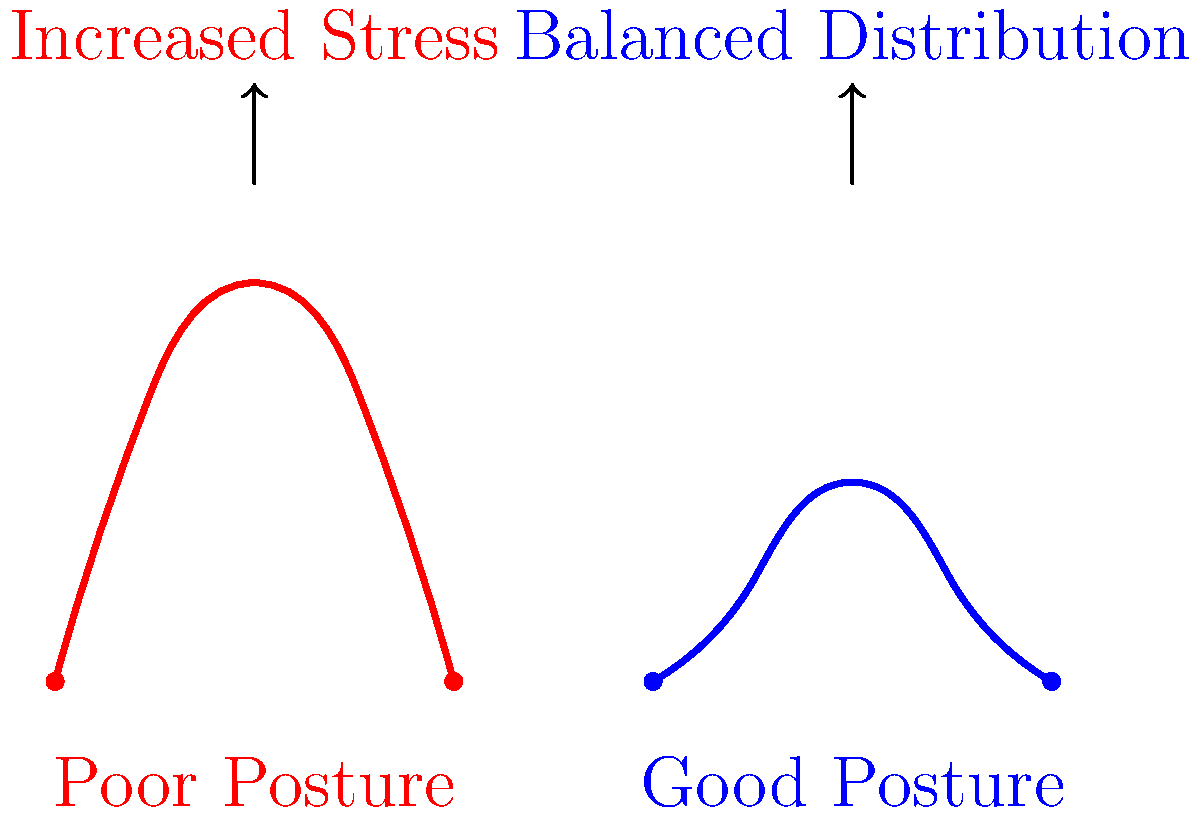Based on the skeletal diagrams shown, which posture is more likely to lead to chronic back pain and why? How does this relate to the concept of "personal responsibility" often emphasized in conservative ideology? 1. Analyze the diagrams:
   - The red curve represents poor posture, with an exaggerated S-shape.
   - The blue curve represents good posture, with a more balanced, gentle curve.

2. Biomechanical implications:
   - Poor posture (red) shows increased curvature, leading to:
     a. Uneven distribution of forces along the spine
     b. Increased stress on certain vertebrae and surrounding muscles
     c. Potential compression of nerves and blood vessels

   - Good posture (blue) demonstrates:
     a. More even distribution of forces
     b. Reduced stress on individual vertebrae and muscles
     c. Better alignment, reducing the risk of nerve and blood vessel compression

3. Long-term effects:
   - Poor posture is more likely to lead to chronic back pain due to:
     a. Repetitive stress on specific areas of the spine
     b. Muscle imbalances and fatigue
     c. Potential disc degeneration and nerve impingement

4. Relation to conservative ideology:
   - Personal responsibility is a key tenet of conservative thought
   - Maintaining good posture can be seen as taking responsibility for one's health
   - Preventive measures (like proper posture) align with the idea of self-reliance and reducing dependence on healthcare systems

5. Conservative perspective:
   - Emphasizes individual choices in health outcomes
   - Suggests that people should be educated about proper posture and take action to prevent future health issues
   - Aligns with the belief that personal habits and choices significantly impact overall well-being
Answer: Poor posture leads to chronic back pain due to uneven stress distribution and misalignment. This relates to personal responsibility in conservative ideology, emphasizing individual choices in health outcomes. 